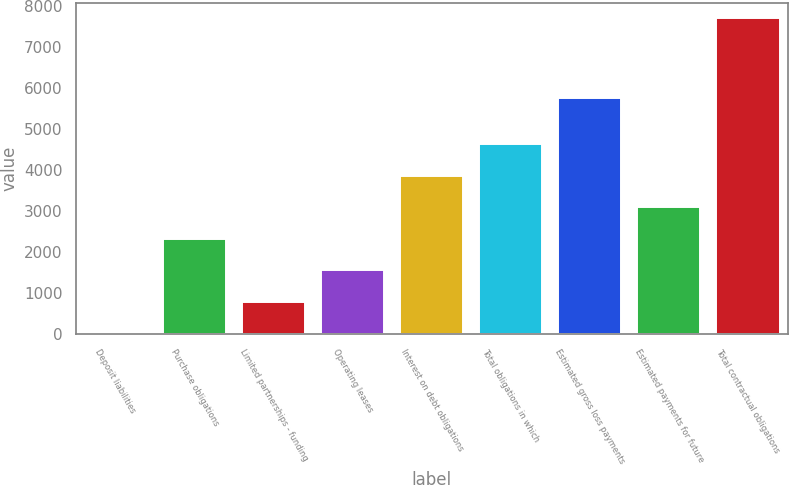Convert chart. <chart><loc_0><loc_0><loc_500><loc_500><bar_chart><fcel>Deposit liabilities<fcel>Purchase obligations<fcel>Limited partnerships - funding<fcel>Operating leases<fcel>Interest on debt obligations<fcel>Total obligations in which<fcel>Estimated gross loss payments<fcel>Estimated payments for future<fcel>Total contractual obligations<nl><fcel>25<fcel>2327.5<fcel>792.5<fcel>1560<fcel>3862.5<fcel>4630<fcel>5760<fcel>3095<fcel>7700<nl></chart> 